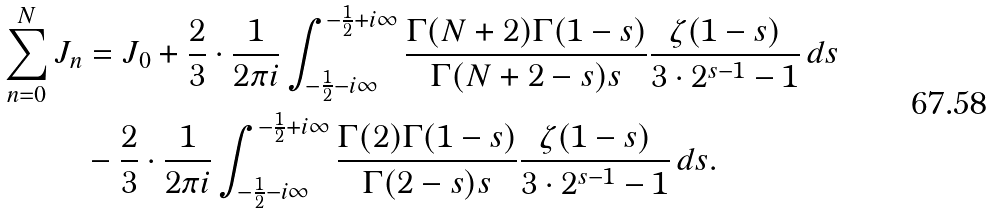Convert formula to latex. <formula><loc_0><loc_0><loc_500><loc_500>\sum _ { n = 0 } ^ { N } J _ { n } & = J _ { 0 } + \frac { 2 } { 3 } \cdot \frac { 1 } { 2 \pi i } \int _ { - \frac { 1 } { 2 } - i \infty } ^ { - \frac { 1 } { 2 } + i \infty } \frac { \Gamma ( N + 2 ) \Gamma ( 1 - s ) } { \Gamma ( N + 2 - s ) s } \frac { \zeta ( 1 - s ) } { 3 \cdot 2 ^ { s - 1 } - 1 } \, d s \\ & - \frac { 2 } { 3 } \cdot \frac { 1 } { 2 \pi i } \int _ { - \frac { 1 } { 2 } - i \infty } ^ { - \frac { 1 } { 2 } + i \infty } \frac { \Gamma ( 2 ) \Gamma ( 1 - s ) } { \Gamma ( 2 - s ) s } \frac { \zeta ( 1 - s ) } { 3 \cdot 2 ^ { s - 1 } - 1 } \, d s .</formula> 